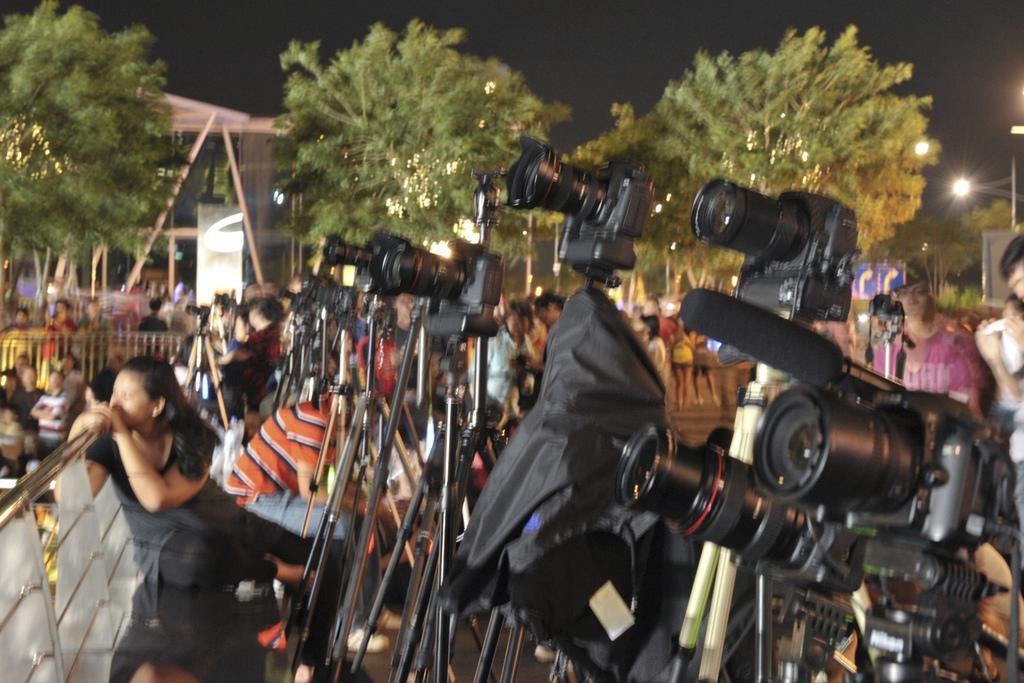In one or two sentences, can you explain what this image depicts? In this image, there are a few people. We can see some camera stands. We can see some wood. We can see an arch. There are a few trees. We can see some lights. We can see a signboard. We can see the sky. We can see the ground. 